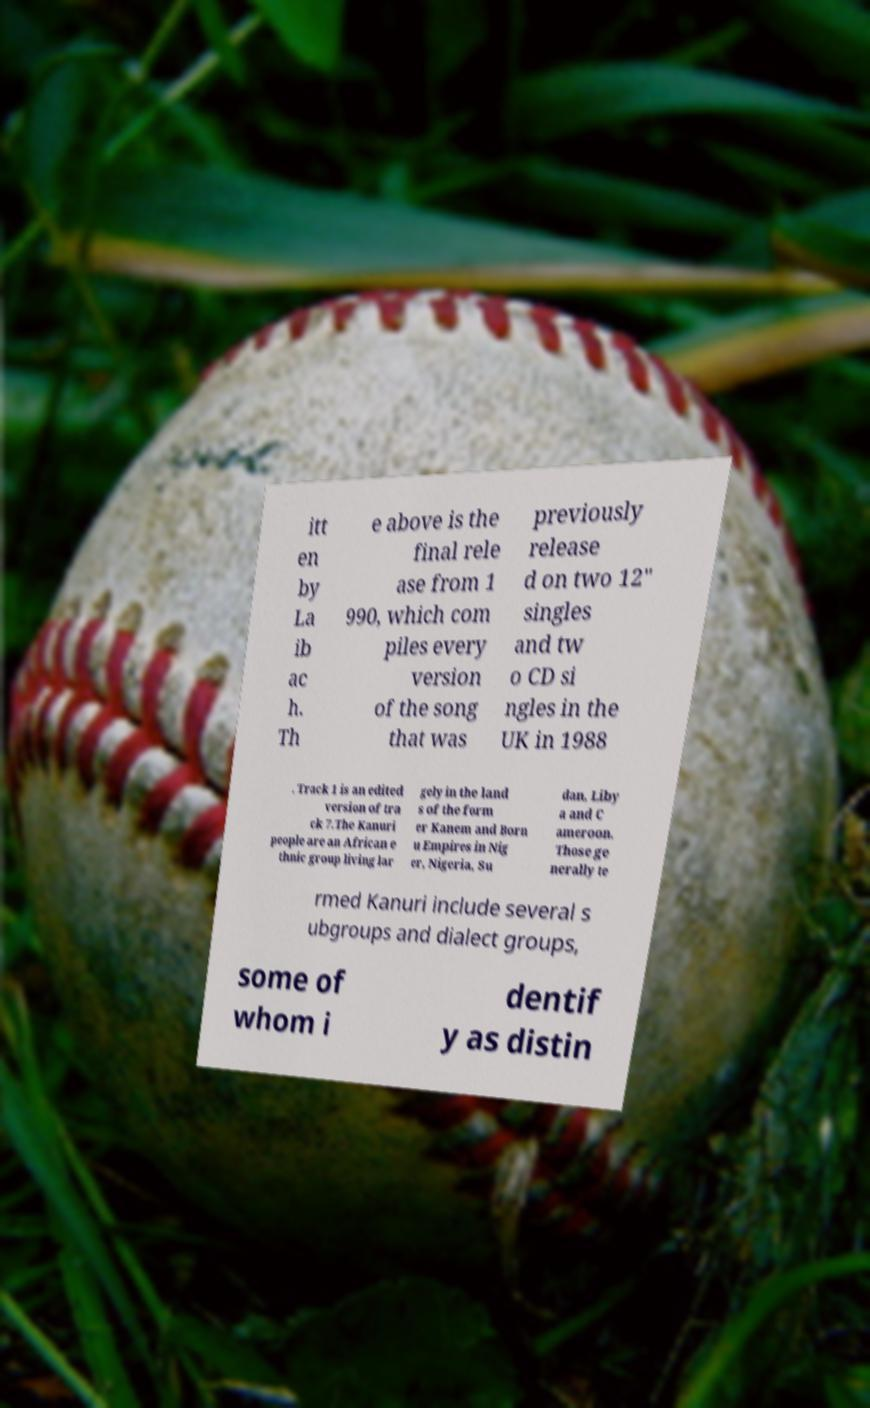There's text embedded in this image that I need extracted. Can you transcribe it verbatim? itt en by La ib ac h. Th e above is the final rele ase from 1 990, which com piles every version of the song that was previously release d on two 12" singles and tw o CD si ngles in the UK in 1988 . Track 1 is an edited version of tra ck 7.The Kanuri people are an African e thnic group living lar gely in the land s of the form er Kanem and Born u Empires in Nig er, Nigeria, Su dan, Liby a and C ameroon. Those ge nerally te rmed Kanuri include several s ubgroups and dialect groups, some of whom i dentif y as distin 